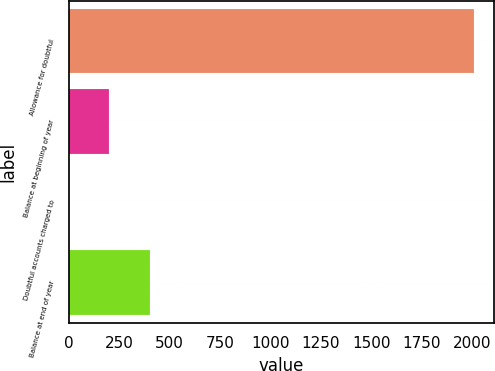<chart> <loc_0><loc_0><loc_500><loc_500><bar_chart><fcel>Allowance for doubtful<fcel>Balance at beginning of year<fcel>Doubtful accounts charged to<fcel>Balance at end of year<nl><fcel>2010<fcel>201.9<fcel>1<fcel>402.8<nl></chart> 